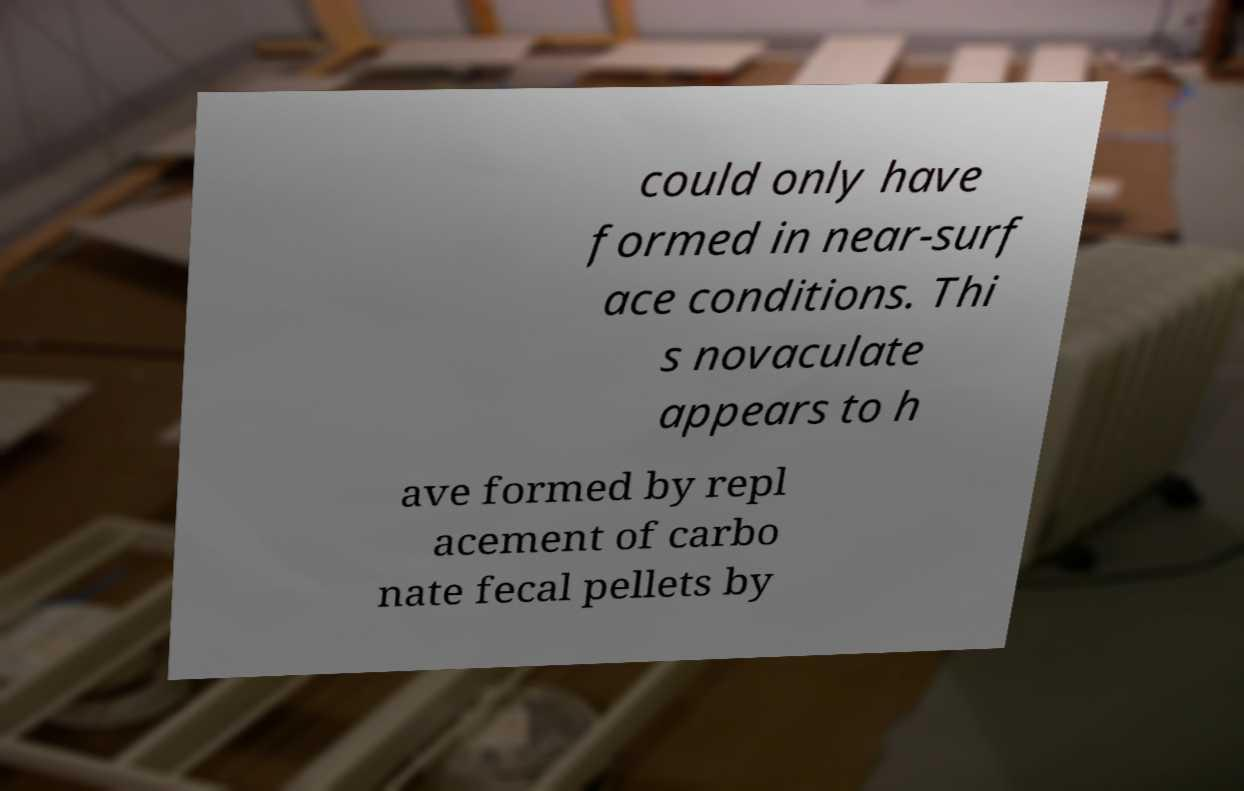There's text embedded in this image that I need extracted. Can you transcribe it verbatim? could only have formed in near-surf ace conditions. Thi s novaculate appears to h ave formed by repl acement of carbo nate fecal pellets by 